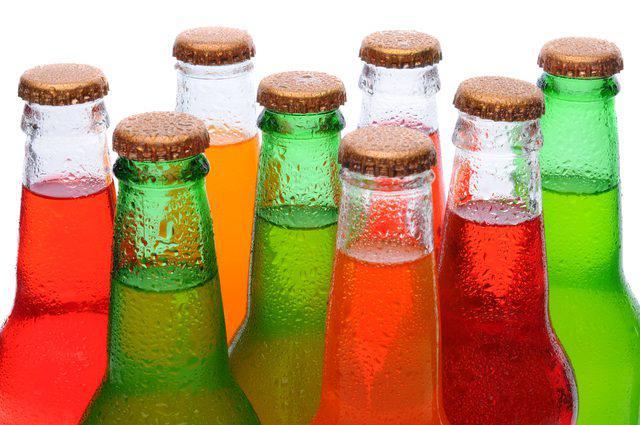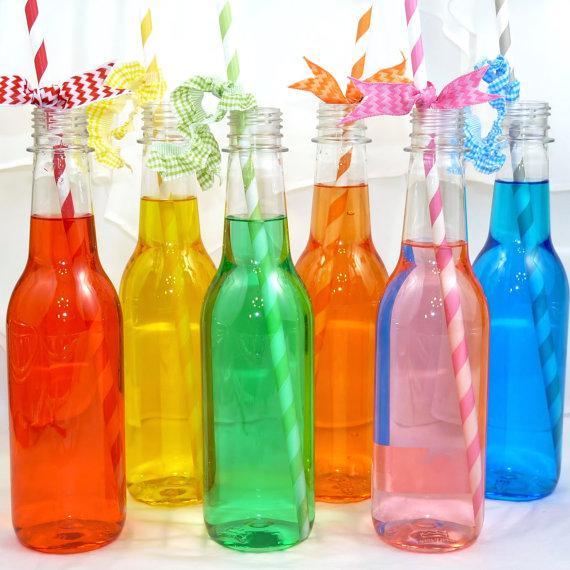The first image is the image on the left, the second image is the image on the right. Considering the images on both sides, is "There are nine drink bottles in total." valid? Answer yes or no. No. The first image is the image on the left, the second image is the image on the right. Evaluate the accuracy of this statement regarding the images: "There are four uncapped bottles in the left image.". Is it true? Answer yes or no. No. 